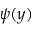<formula> <loc_0><loc_0><loc_500><loc_500>\psi ( y )</formula> 